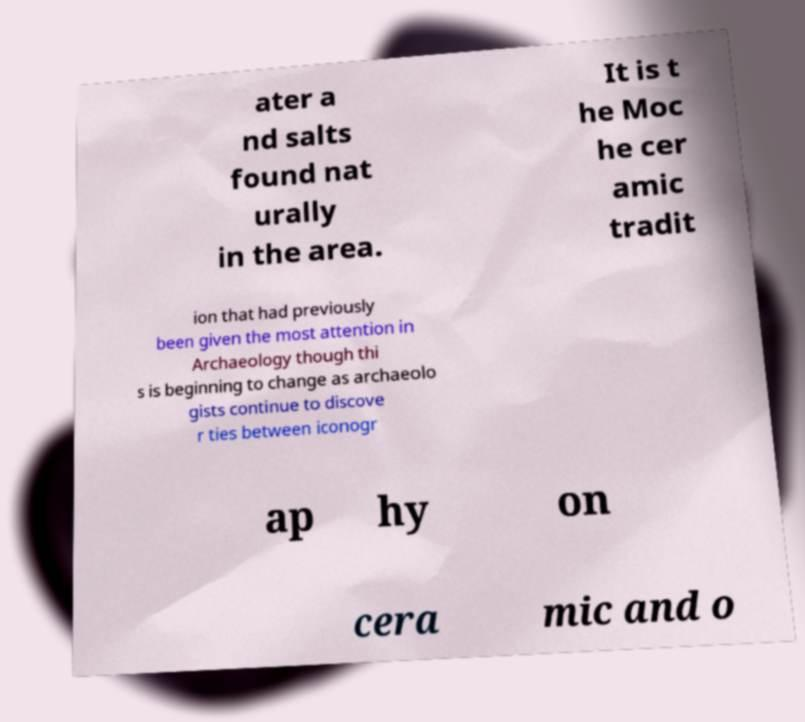I need the written content from this picture converted into text. Can you do that? ater a nd salts found nat urally in the area. It is t he Moc he cer amic tradit ion that had previously been given the most attention in Archaeology though thi s is beginning to change as archaeolo gists continue to discove r ties between iconogr ap hy on cera mic and o 